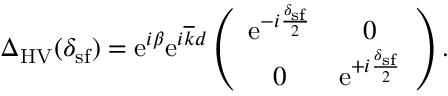Convert formula to latex. <formula><loc_0><loc_0><loc_500><loc_500>\begin{array} { r } { \Delta _ { H V } ( \delta _ { s f } ) = e ^ { i \beta } e ^ { i \overline { k } d } \left ( \begin{array} { c c } { e ^ { - i \frac { \delta _ { s f } } { 2 } } } & { 0 } \\ { 0 } & { e ^ { + i \frac { \delta _ { s f } } { 2 } } } \end{array} \right ) . } \end{array}</formula> 